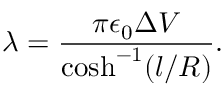<formula> <loc_0><loc_0><loc_500><loc_500>\lambda = \frac { \pi \epsilon _ { 0 } \Delta V } { \cosh ^ { - 1 } ( l / R ) } .</formula> 